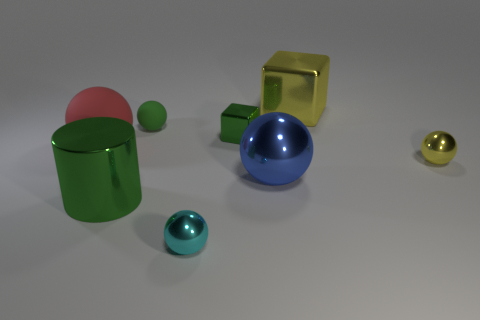Subtract all big metallic spheres. How many spheres are left? 4 Subtract all yellow spheres. How many spheres are left? 4 Subtract all cyan balls. Subtract all purple cylinders. How many balls are left? 4 Add 1 brown rubber objects. How many objects exist? 9 Subtract all cubes. How many objects are left? 6 Subtract 0 yellow cylinders. How many objects are left? 8 Subtract all green objects. Subtract all small metal balls. How many objects are left? 3 Add 3 large blue metallic balls. How many large blue metallic balls are left? 4 Add 4 green metallic objects. How many green metallic objects exist? 6 